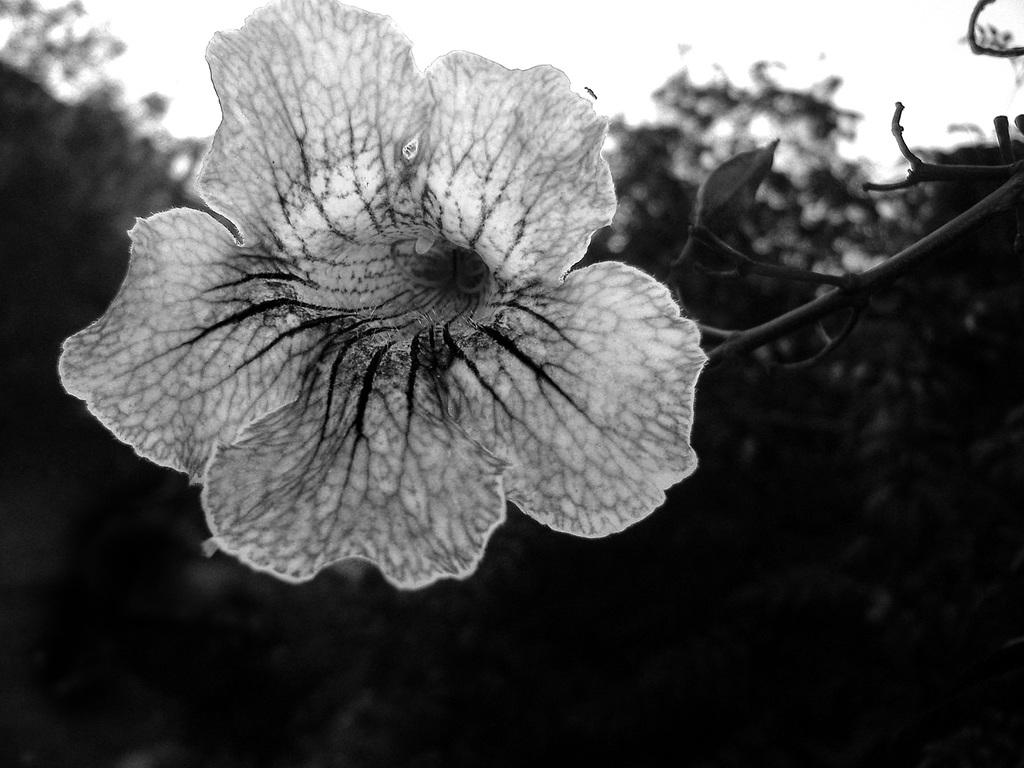What is the main subject of the image? There is a flower in the image. What part of the flower is visible in the image? There is a stem in the image. What color is the background of the image? The background of the image is blue. What type of drug can be seen in the image? There is no drug present in the image; it features a flower and a blue background. How many people are in the crowd in the image? There is no crowd present in the image; it only contains a flower and a blue background. 